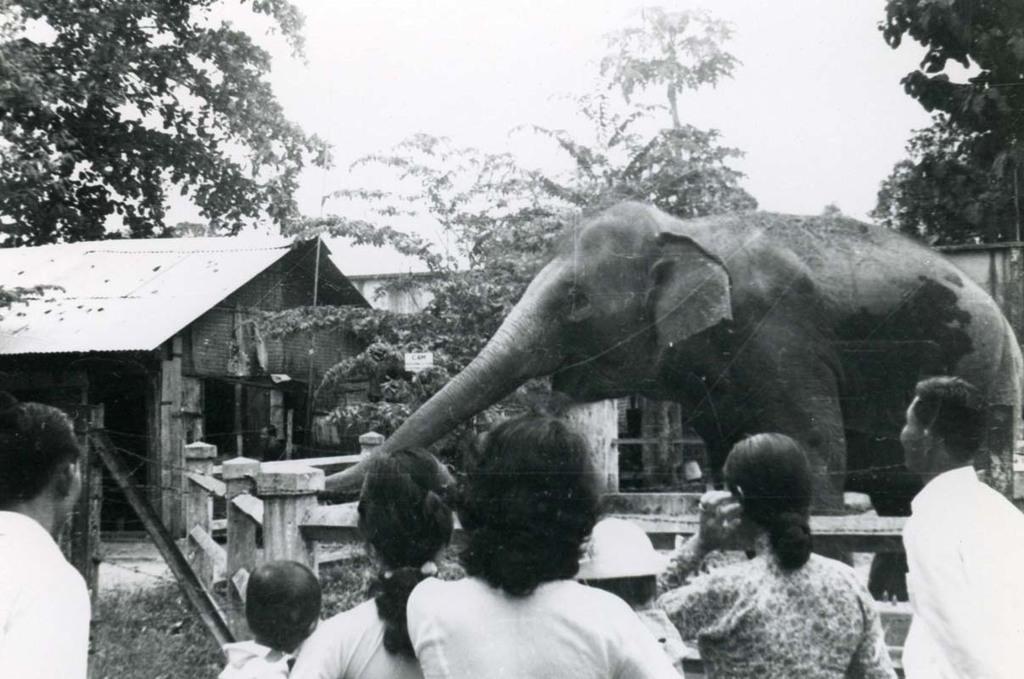Describe this image in one or two sentences. There are few persons looking at the elephant in front of them and there are trees and houses in the background. 